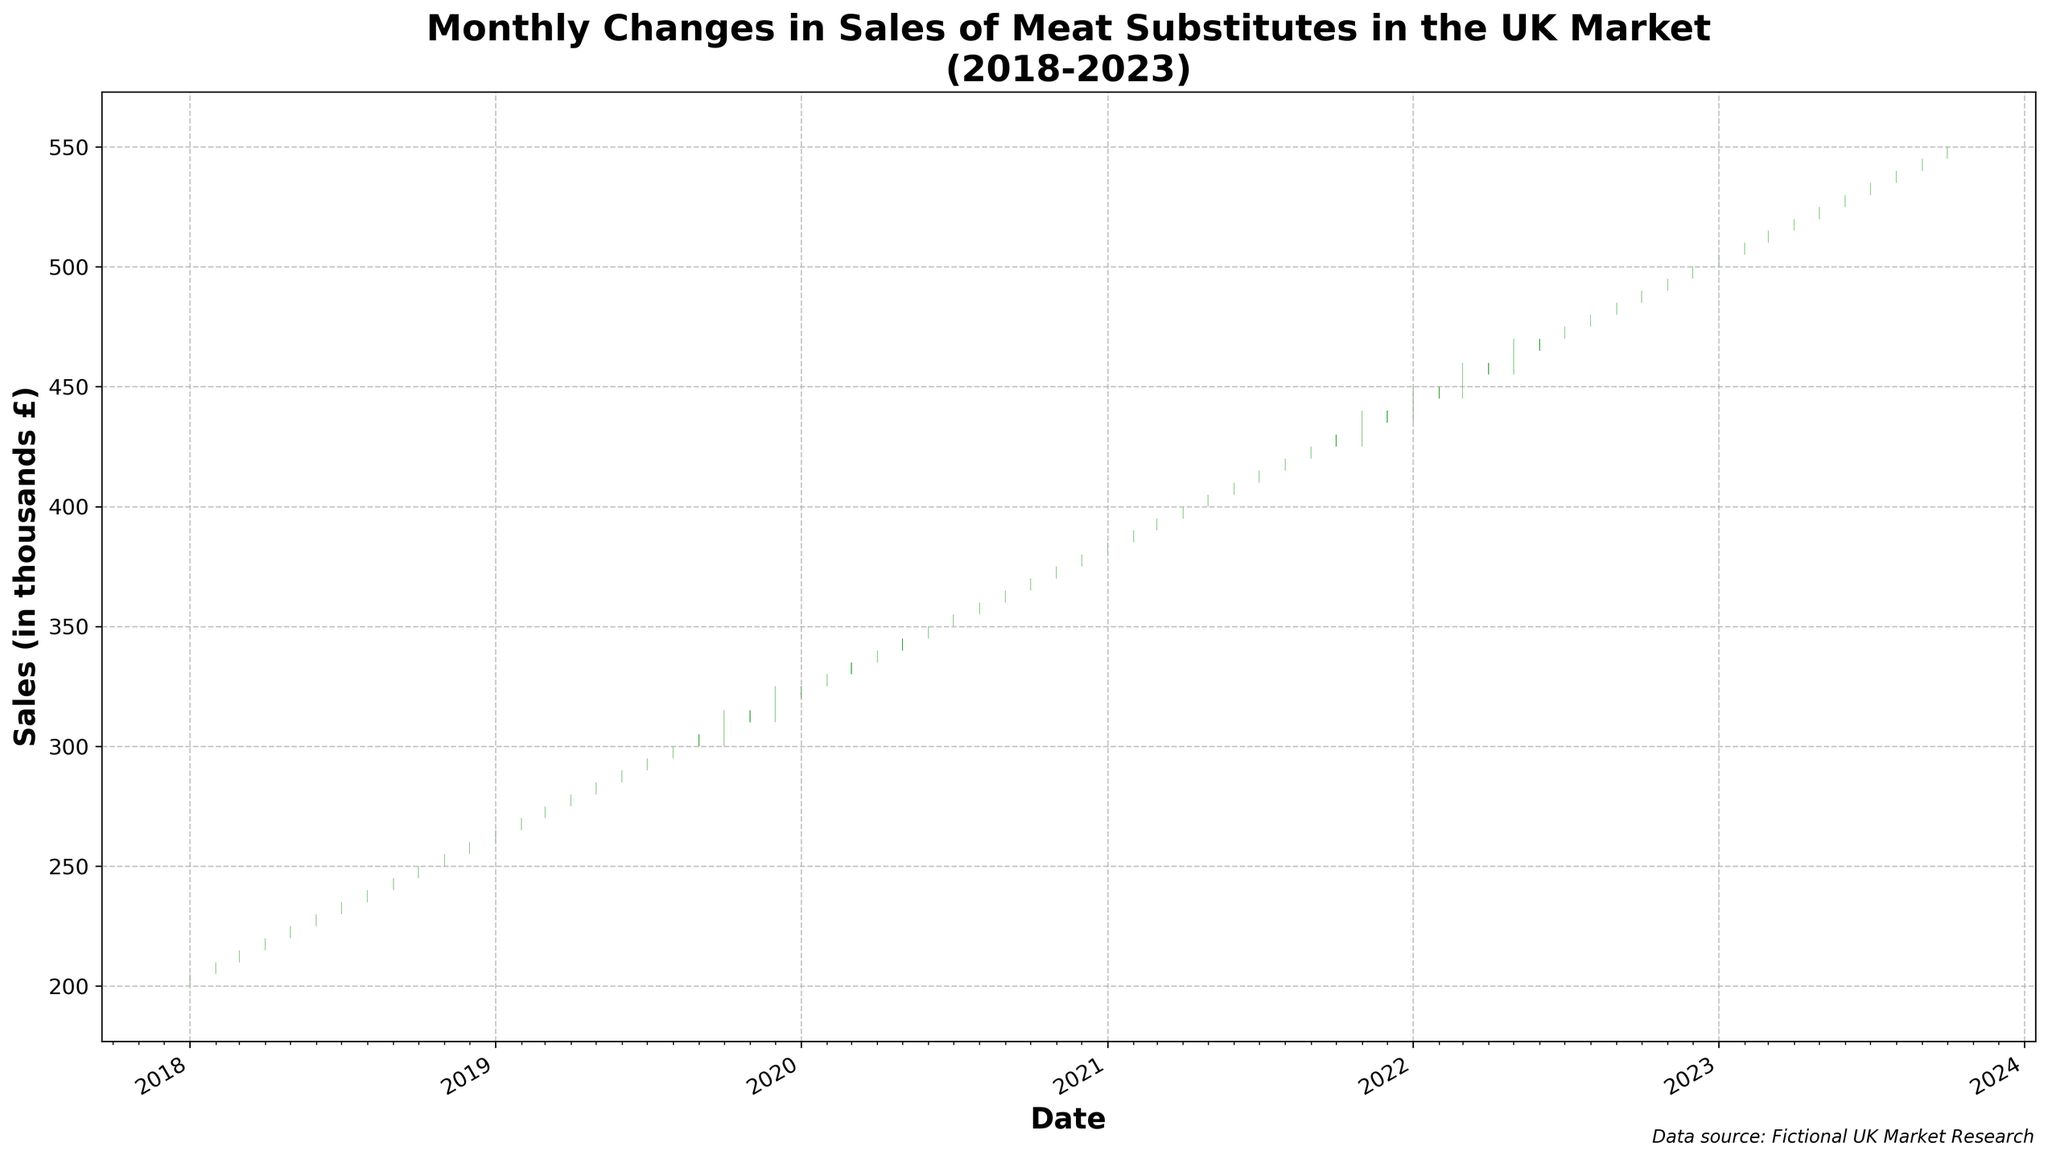What is the title of the chart? The title is typically found at the top of the chart, clearly stating the subject matter being depicted. By looking at the top of the chart, you can see the text titled 'Monthly Changes in Sales of Meat Substitutes in the UK Market (2018-2023)'.
Answer: Monthly Changes in Sales of Meat Substitutes in the UK Market (2018-2023) What is the range of the y-axis? The y-axis usually indicates the range of data values. On examining the y-axis in this figure, it spans from 0 thousand £ to 600 thousand £, but primarily covers the data range shown in the bars.
Answer: 195 thousand £ to 555 thousand £ How is an increase in sales represented in the candlestick plot? In a candlestick plot, the color and structure of the candlestick indicate changes in data. Here, an increase in sales is represented by green bars, indicating that the closing value is higher than the opening value.
Answer: Green bars Which month had the highest closing sales value in the dataset? To find the highest closing sales value, you look at the length and position of the bars. The topmost point of the closing green candlestick represents the highest value, which occurs in October 2023.
Answer: October 2023 How many times in the span of 2018-2023 did the close price equal the open price? For close price equal to open price, the candlestick would be a narrow line without any body since there's no change from open to close. Scanning through the chart confirms that this scenario did not occur.
Answer: 0 times What was the percentage increase in sales from January 2018 to October 2023? Percentage increase = ((final value - initial value) / initial value) * 100. From January 2018 (205 thousand £) to October 2023 (550 thousand £), the calculation is ((550 - 205) / 205) * 100 = 168.29%.
Answer: 168.29% Identify a period of steep increase in the sales within the given timeframe. A steep increase would be visible as a series of consecutive long green candlesticks. From March 2020 to July 2020, there is a notable steep increase as the sales rise each month without any red candlesticks.
Answer: March 2020 to July 2020 Compare the average sales value of 2018 and 2023 up to October. Which year had higher average sales? Calculate average sales (sum of all closing values divided by the number of months). For 2018: (205 + 210 + 215 + 220 + 225 + 230 + 235 + 240 + 245 + 250 + 255 + 260) / 12 = 232.5 thousand £. For 2023: (505 + 510 + 515 + 520 + 525 + 530 + 535 + 540 + 545) / 9 = 522.78 thousand £. 2023 has higher average sales.
Answer: 2023 Did sales ever decrease for more than two consecutive months? Look for sequences of red candlesticks which indicate consecutive monthly decrease. There are no cases where there are more than two consecutive red candlesticks in the dataset.
Answer: No What was the lowest recorded sales value in the five years? To identify the lowest sales value, examine the lowest point of the candlesticks on the plot. The lowest sales value (195 thousand £) appears in January 2018 as indicated by the lowest bottom of the red candlestick.
Answer: 195 thousand £ 